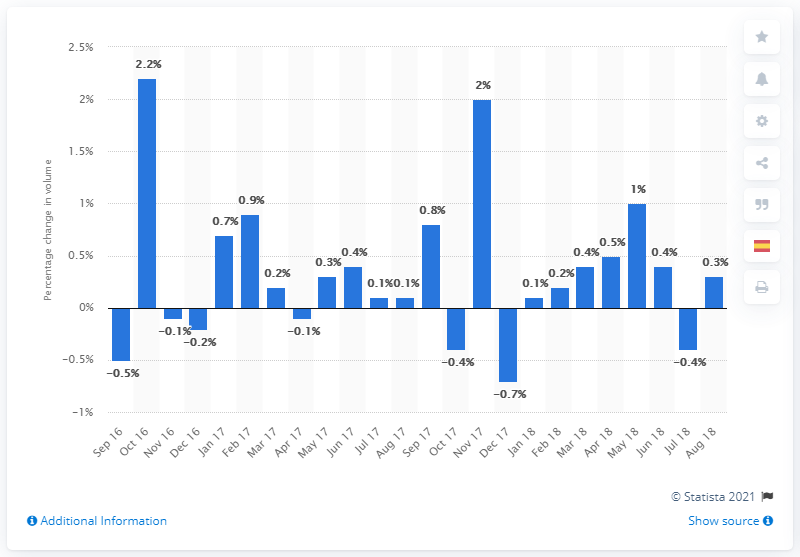Identify some key points in this picture. Retail trade volumes increased by 0.3% in August 2018 compared to the previous month. 